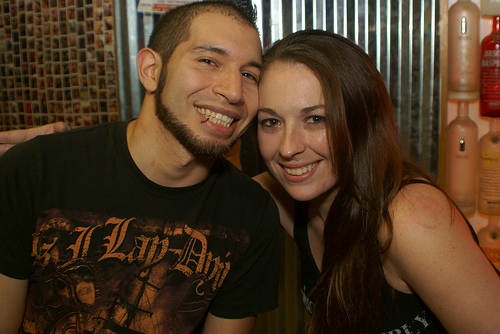<image>
Is the girl under the boy? No. The girl is not positioned under the boy. The vertical relationship between these objects is different. Where is the bottle in relation to the wall? Is it next to the wall? Yes. The bottle is positioned adjacent to the wall, located nearby in the same general area. Is there a girl in front of the wine? Yes. The girl is positioned in front of the wine, appearing closer to the camera viewpoint. 